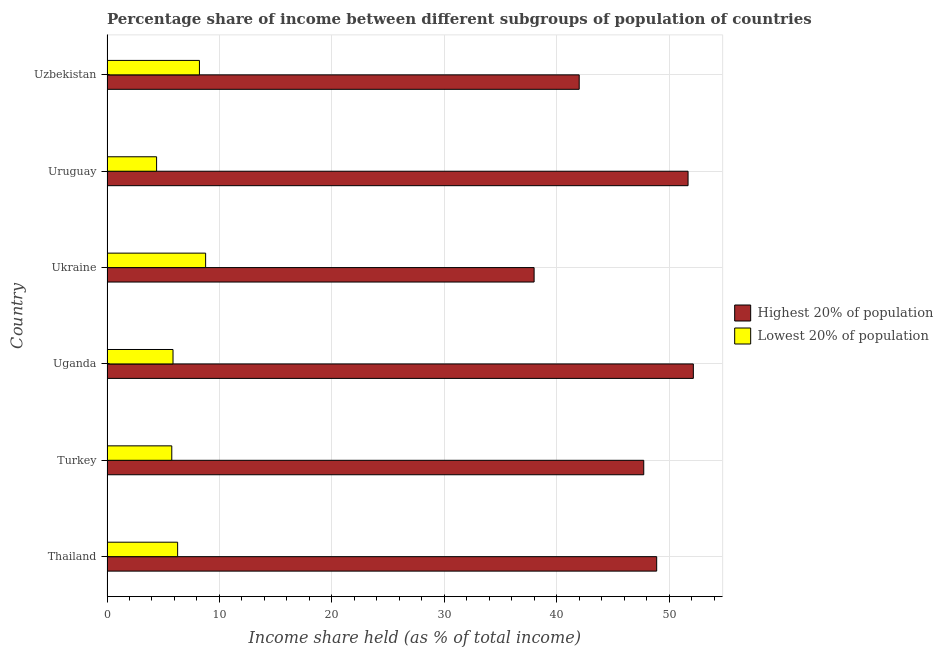How many different coloured bars are there?
Your response must be concise. 2. How many bars are there on the 1st tick from the top?
Your response must be concise. 2. What is the label of the 4th group of bars from the top?
Keep it short and to the point. Uganda. In how many cases, is the number of bars for a given country not equal to the number of legend labels?
Your response must be concise. 0. What is the income share held by highest 20% of the population in Uganda?
Keep it short and to the point. 52.14. Across all countries, what is the maximum income share held by highest 20% of the population?
Your response must be concise. 52.14. Across all countries, what is the minimum income share held by lowest 20% of the population?
Provide a short and direct response. 4.41. In which country was the income share held by lowest 20% of the population maximum?
Provide a short and direct response. Ukraine. In which country was the income share held by lowest 20% of the population minimum?
Offer a very short reply. Uruguay. What is the total income share held by lowest 20% of the population in the graph?
Give a very brief answer. 39.31. What is the difference between the income share held by lowest 20% of the population in Uzbekistan and the income share held by highest 20% of the population in Turkey?
Keep it short and to the point. -39.51. What is the average income share held by lowest 20% of the population per country?
Provide a succinct answer. 6.55. What is the difference between the income share held by highest 20% of the population and income share held by lowest 20% of the population in Uganda?
Your answer should be compact. 46.27. What is the ratio of the income share held by lowest 20% of the population in Thailand to that in Turkey?
Your answer should be compact. 1.09. What is the difference between the highest and the second highest income share held by lowest 20% of the population?
Keep it short and to the point. 0.55. What is the difference between the highest and the lowest income share held by highest 20% of the population?
Provide a succinct answer. 14.16. In how many countries, is the income share held by lowest 20% of the population greater than the average income share held by lowest 20% of the population taken over all countries?
Give a very brief answer. 2. What does the 1st bar from the top in Turkey represents?
Your answer should be very brief. Lowest 20% of population. What does the 1st bar from the bottom in Uruguay represents?
Make the answer very short. Highest 20% of population. Are all the bars in the graph horizontal?
Keep it short and to the point. Yes. How many countries are there in the graph?
Ensure brevity in your answer.  6. What is the difference between two consecutive major ticks on the X-axis?
Your answer should be compact. 10. Does the graph contain grids?
Your response must be concise. Yes. How are the legend labels stacked?
Offer a terse response. Vertical. What is the title of the graph?
Provide a succinct answer. Percentage share of income between different subgroups of population of countries. Does "Merchandise exports" appear as one of the legend labels in the graph?
Your response must be concise. No. What is the label or title of the X-axis?
Your answer should be compact. Income share held (as % of total income). What is the Income share held (as % of total income) of Highest 20% of population in Thailand?
Your answer should be compact. 48.88. What is the Income share held (as % of total income) of Lowest 20% of population in Thailand?
Provide a succinct answer. 6.28. What is the Income share held (as % of total income) in Highest 20% of population in Turkey?
Offer a terse response. 47.73. What is the Income share held (as % of total income) of Lowest 20% of population in Turkey?
Your answer should be compact. 5.76. What is the Income share held (as % of total income) of Highest 20% of population in Uganda?
Keep it short and to the point. 52.14. What is the Income share held (as % of total income) in Lowest 20% of population in Uganda?
Make the answer very short. 5.87. What is the Income share held (as % of total income) of Highest 20% of population in Ukraine?
Give a very brief answer. 37.98. What is the Income share held (as % of total income) of Lowest 20% of population in Ukraine?
Give a very brief answer. 8.77. What is the Income share held (as % of total income) of Highest 20% of population in Uruguay?
Offer a very short reply. 51.67. What is the Income share held (as % of total income) in Lowest 20% of population in Uruguay?
Your answer should be compact. 4.41. What is the Income share held (as % of total income) in Highest 20% of population in Uzbekistan?
Give a very brief answer. 41.99. What is the Income share held (as % of total income) of Lowest 20% of population in Uzbekistan?
Offer a very short reply. 8.22. Across all countries, what is the maximum Income share held (as % of total income) of Highest 20% of population?
Offer a very short reply. 52.14. Across all countries, what is the maximum Income share held (as % of total income) of Lowest 20% of population?
Ensure brevity in your answer.  8.77. Across all countries, what is the minimum Income share held (as % of total income) of Highest 20% of population?
Your response must be concise. 37.98. Across all countries, what is the minimum Income share held (as % of total income) in Lowest 20% of population?
Your answer should be compact. 4.41. What is the total Income share held (as % of total income) of Highest 20% of population in the graph?
Your response must be concise. 280.39. What is the total Income share held (as % of total income) in Lowest 20% of population in the graph?
Provide a short and direct response. 39.31. What is the difference between the Income share held (as % of total income) of Highest 20% of population in Thailand and that in Turkey?
Your response must be concise. 1.15. What is the difference between the Income share held (as % of total income) of Lowest 20% of population in Thailand and that in Turkey?
Provide a succinct answer. 0.52. What is the difference between the Income share held (as % of total income) of Highest 20% of population in Thailand and that in Uganda?
Offer a very short reply. -3.26. What is the difference between the Income share held (as % of total income) in Lowest 20% of population in Thailand and that in Uganda?
Offer a very short reply. 0.41. What is the difference between the Income share held (as % of total income) in Highest 20% of population in Thailand and that in Ukraine?
Your response must be concise. 10.9. What is the difference between the Income share held (as % of total income) of Lowest 20% of population in Thailand and that in Ukraine?
Give a very brief answer. -2.49. What is the difference between the Income share held (as % of total income) in Highest 20% of population in Thailand and that in Uruguay?
Offer a very short reply. -2.79. What is the difference between the Income share held (as % of total income) in Lowest 20% of population in Thailand and that in Uruguay?
Your answer should be very brief. 1.87. What is the difference between the Income share held (as % of total income) in Highest 20% of population in Thailand and that in Uzbekistan?
Offer a very short reply. 6.89. What is the difference between the Income share held (as % of total income) of Lowest 20% of population in Thailand and that in Uzbekistan?
Provide a short and direct response. -1.94. What is the difference between the Income share held (as % of total income) of Highest 20% of population in Turkey and that in Uganda?
Keep it short and to the point. -4.41. What is the difference between the Income share held (as % of total income) in Lowest 20% of population in Turkey and that in Uganda?
Provide a short and direct response. -0.11. What is the difference between the Income share held (as % of total income) of Highest 20% of population in Turkey and that in Ukraine?
Offer a very short reply. 9.75. What is the difference between the Income share held (as % of total income) of Lowest 20% of population in Turkey and that in Ukraine?
Ensure brevity in your answer.  -3.01. What is the difference between the Income share held (as % of total income) of Highest 20% of population in Turkey and that in Uruguay?
Your answer should be compact. -3.94. What is the difference between the Income share held (as % of total income) in Lowest 20% of population in Turkey and that in Uruguay?
Your response must be concise. 1.35. What is the difference between the Income share held (as % of total income) in Highest 20% of population in Turkey and that in Uzbekistan?
Offer a very short reply. 5.74. What is the difference between the Income share held (as % of total income) in Lowest 20% of population in Turkey and that in Uzbekistan?
Make the answer very short. -2.46. What is the difference between the Income share held (as % of total income) in Highest 20% of population in Uganda and that in Ukraine?
Offer a terse response. 14.16. What is the difference between the Income share held (as % of total income) in Lowest 20% of population in Uganda and that in Ukraine?
Your answer should be compact. -2.9. What is the difference between the Income share held (as % of total income) in Highest 20% of population in Uganda and that in Uruguay?
Make the answer very short. 0.47. What is the difference between the Income share held (as % of total income) in Lowest 20% of population in Uganda and that in Uruguay?
Offer a terse response. 1.46. What is the difference between the Income share held (as % of total income) in Highest 20% of population in Uganda and that in Uzbekistan?
Make the answer very short. 10.15. What is the difference between the Income share held (as % of total income) in Lowest 20% of population in Uganda and that in Uzbekistan?
Offer a very short reply. -2.35. What is the difference between the Income share held (as % of total income) in Highest 20% of population in Ukraine and that in Uruguay?
Make the answer very short. -13.69. What is the difference between the Income share held (as % of total income) of Lowest 20% of population in Ukraine and that in Uruguay?
Your answer should be compact. 4.36. What is the difference between the Income share held (as % of total income) of Highest 20% of population in Ukraine and that in Uzbekistan?
Your answer should be very brief. -4.01. What is the difference between the Income share held (as % of total income) of Lowest 20% of population in Ukraine and that in Uzbekistan?
Your response must be concise. 0.55. What is the difference between the Income share held (as % of total income) in Highest 20% of population in Uruguay and that in Uzbekistan?
Offer a very short reply. 9.68. What is the difference between the Income share held (as % of total income) in Lowest 20% of population in Uruguay and that in Uzbekistan?
Provide a short and direct response. -3.81. What is the difference between the Income share held (as % of total income) of Highest 20% of population in Thailand and the Income share held (as % of total income) of Lowest 20% of population in Turkey?
Your answer should be very brief. 43.12. What is the difference between the Income share held (as % of total income) of Highest 20% of population in Thailand and the Income share held (as % of total income) of Lowest 20% of population in Uganda?
Your answer should be very brief. 43.01. What is the difference between the Income share held (as % of total income) of Highest 20% of population in Thailand and the Income share held (as % of total income) of Lowest 20% of population in Ukraine?
Make the answer very short. 40.11. What is the difference between the Income share held (as % of total income) in Highest 20% of population in Thailand and the Income share held (as % of total income) in Lowest 20% of population in Uruguay?
Keep it short and to the point. 44.47. What is the difference between the Income share held (as % of total income) in Highest 20% of population in Thailand and the Income share held (as % of total income) in Lowest 20% of population in Uzbekistan?
Your answer should be compact. 40.66. What is the difference between the Income share held (as % of total income) of Highest 20% of population in Turkey and the Income share held (as % of total income) of Lowest 20% of population in Uganda?
Provide a short and direct response. 41.86. What is the difference between the Income share held (as % of total income) of Highest 20% of population in Turkey and the Income share held (as % of total income) of Lowest 20% of population in Ukraine?
Offer a very short reply. 38.96. What is the difference between the Income share held (as % of total income) of Highest 20% of population in Turkey and the Income share held (as % of total income) of Lowest 20% of population in Uruguay?
Ensure brevity in your answer.  43.32. What is the difference between the Income share held (as % of total income) in Highest 20% of population in Turkey and the Income share held (as % of total income) in Lowest 20% of population in Uzbekistan?
Keep it short and to the point. 39.51. What is the difference between the Income share held (as % of total income) of Highest 20% of population in Uganda and the Income share held (as % of total income) of Lowest 20% of population in Ukraine?
Give a very brief answer. 43.37. What is the difference between the Income share held (as % of total income) of Highest 20% of population in Uganda and the Income share held (as % of total income) of Lowest 20% of population in Uruguay?
Provide a short and direct response. 47.73. What is the difference between the Income share held (as % of total income) in Highest 20% of population in Uganda and the Income share held (as % of total income) in Lowest 20% of population in Uzbekistan?
Give a very brief answer. 43.92. What is the difference between the Income share held (as % of total income) in Highest 20% of population in Ukraine and the Income share held (as % of total income) in Lowest 20% of population in Uruguay?
Keep it short and to the point. 33.57. What is the difference between the Income share held (as % of total income) of Highest 20% of population in Ukraine and the Income share held (as % of total income) of Lowest 20% of population in Uzbekistan?
Offer a terse response. 29.76. What is the difference between the Income share held (as % of total income) in Highest 20% of population in Uruguay and the Income share held (as % of total income) in Lowest 20% of population in Uzbekistan?
Your answer should be compact. 43.45. What is the average Income share held (as % of total income) in Highest 20% of population per country?
Your answer should be compact. 46.73. What is the average Income share held (as % of total income) in Lowest 20% of population per country?
Give a very brief answer. 6.55. What is the difference between the Income share held (as % of total income) of Highest 20% of population and Income share held (as % of total income) of Lowest 20% of population in Thailand?
Offer a terse response. 42.6. What is the difference between the Income share held (as % of total income) in Highest 20% of population and Income share held (as % of total income) in Lowest 20% of population in Turkey?
Your answer should be very brief. 41.97. What is the difference between the Income share held (as % of total income) in Highest 20% of population and Income share held (as % of total income) in Lowest 20% of population in Uganda?
Your response must be concise. 46.27. What is the difference between the Income share held (as % of total income) in Highest 20% of population and Income share held (as % of total income) in Lowest 20% of population in Ukraine?
Your response must be concise. 29.21. What is the difference between the Income share held (as % of total income) of Highest 20% of population and Income share held (as % of total income) of Lowest 20% of population in Uruguay?
Make the answer very short. 47.26. What is the difference between the Income share held (as % of total income) of Highest 20% of population and Income share held (as % of total income) of Lowest 20% of population in Uzbekistan?
Make the answer very short. 33.77. What is the ratio of the Income share held (as % of total income) of Highest 20% of population in Thailand to that in Turkey?
Ensure brevity in your answer.  1.02. What is the ratio of the Income share held (as % of total income) in Lowest 20% of population in Thailand to that in Turkey?
Ensure brevity in your answer.  1.09. What is the ratio of the Income share held (as % of total income) in Lowest 20% of population in Thailand to that in Uganda?
Keep it short and to the point. 1.07. What is the ratio of the Income share held (as % of total income) of Highest 20% of population in Thailand to that in Ukraine?
Provide a succinct answer. 1.29. What is the ratio of the Income share held (as % of total income) in Lowest 20% of population in Thailand to that in Ukraine?
Give a very brief answer. 0.72. What is the ratio of the Income share held (as % of total income) in Highest 20% of population in Thailand to that in Uruguay?
Provide a succinct answer. 0.95. What is the ratio of the Income share held (as % of total income) of Lowest 20% of population in Thailand to that in Uruguay?
Provide a succinct answer. 1.42. What is the ratio of the Income share held (as % of total income) in Highest 20% of population in Thailand to that in Uzbekistan?
Make the answer very short. 1.16. What is the ratio of the Income share held (as % of total income) in Lowest 20% of population in Thailand to that in Uzbekistan?
Provide a succinct answer. 0.76. What is the ratio of the Income share held (as % of total income) of Highest 20% of population in Turkey to that in Uganda?
Offer a terse response. 0.92. What is the ratio of the Income share held (as % of total income) in Lowest 20% of population in Turkey to that in Uganda?
Keep it short and to the point. 0.98. What is the ratio of the Income share held (as % of total income) in Highest 20% of population in Turkey to that in Ukraine?
Offer a very short reply. 1.26. What is the ratio of the Income share held (as % of total income) of Lowest 20% of population in Turkey to that in Ukraine?
Make the answer very short. 0.66. What is the ratio of the Income share held (as % of total income) in Highest 20% of population in Turkey to that in Uruguay?
Offer a terse response. 0.92. What is the ratio of the Income share held (as % of total income) in Lowest 20% of population in Turkey to that in Uruguay?
Your response must be concise. 1.31. What is the ratio of the Income share held (as % of total income) in Highest 20% of population in Turkey to that in Uzbekistan?
Give a very brief answer. 1.14. What is the ratio of the Income share held (as % of total income) of Lowest 20% of population in Turkey to that in Uzbekistan?
Your response must be concise. 0.7. What is the ratio of the Income share held (as % of total income) of Highest 20% of population in Uganda to that in Ukraine?
Ensure brevity in your answer.  1.37. What is the ratio of the Income share held (as % of total income) of Lowest 20% of population in Uganda to that in Ukraine?
Give a very brief answer. 0.67. What is the ratio of the Income share held (as % of total income) in Highest 20% of population in Uganda to that in Uruguay?
Provide a short and direct response. 1.01. What is the ratio of the Income share held (as % of total income) in Lowest 20% of population in Uganda to that in Uruguay?
Offer a terse response. 1.33. What is the ratio of the Income share held (as % of total income) in Highest 20% of population in Uganda to that in Uzbekistan?
Give a very brief answer. 1.24. What is the ratio of the Income share held (as % of total income) of Lowest 20% of population in Uganda to that in Uzbekistan?
Give a very brief answer. 0.71. What is the ratio of the Income share held (as % of total income) of Highest 20% of population in Ukraine to that in Uruguay?
Your answer should be very brief. 0.73. What is the ratio of the Income share held (as % of total income) of Lowest 20% of population in Ukraine to that in Uruguay?
Offer a terse response. 1.99. What is the ratio of the Income share held (as % of total income) of Highest 20% of population in Ukraine to that in Uzbekistan?
Your answer should be compact. 0.9. What is the ratio of the Income share held (as % of total income) in Lowest 20% of population in Ukraine to that in Uzbekistan?
Your response must be concise. 1.07. What is the ratio of the Income share held (as % of total income) of Highest 20% of population in Uruguay to that in Uzbekistan?
Offer a terse response. 1.23. What is the ratio of the Income share held (as % of total income) of Lowest 20% of population in Uruguay to that in Uzbekistan?
Provide a short and direct response. 0.54. What is the difference between the highest and the second highest Income share held (as % of total income) in Highest 20% of population?
Offer a very short reply. 0.47. What is the difference between the highest and the second highest Income share held (as % of total income) of Lowest 20% of population?
Ensure brevity in your answer.  0.55. What is the difference between the highest and the lowest Income share held (as % of total income) of Highest 20% of population?
Keep it short and to the point. 14.16. What is the difference between the highest and the lowest Income share held (as % of total income) of Lowest 20% of population?
Keep it short and to the point. 4.36. 